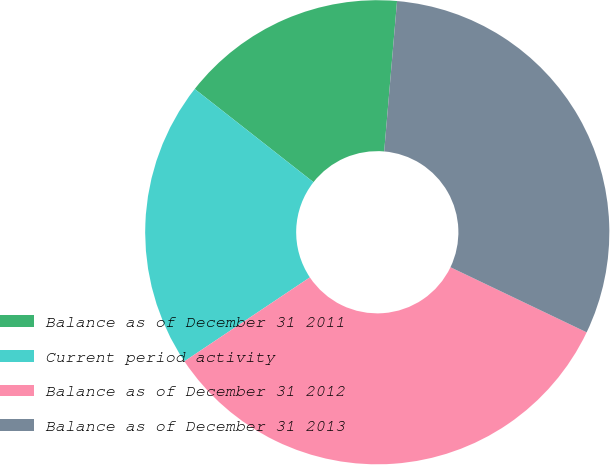Convert chart to OTSL. <chart><loc_0><loc_0><loc_500><loc_500><pie_chart><fcel>Balance as of December 31 2011<fcel>Current period activity<fcel>Balance as of December 31 2012<fcel>Balance as of December 31 2013<nl><fcel>15.77%<fcel>19.98%<fcel>33.52%<fcel>30.74%<nl></chart> 